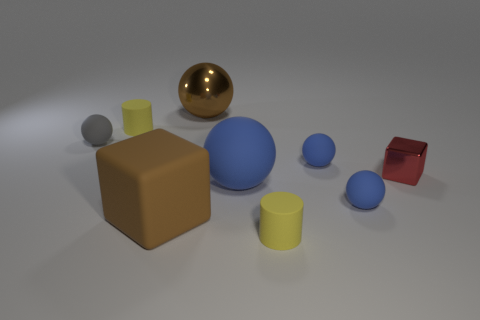What number of other things are there of the same size as the gray matte sphere?
Provide a short and direct response. 5. What number of objects are either blue balls behind the tiny cube or yellow rubber cylinders that are behind the tiny red shiny cube?
Your answer should be compact. 2. Do the big brown block and the tiny cylinder that is behind the red thing have the same material?
Offer a terse response. Yes. How many other objects are there of the same shape as the tiny red metal thing?
Make the answer very short. 1. There is a tiny ball that is on the left side of the yellow cylinder to the left of the small yellow thing in front of the big matte cube; what is it made of?
Keep it short and to the point. Rubber. Are there an equal number of tiny gray matte spheres on the right side of the big blue rubber object and purple cylinders?
Give a very brief answer. Yes. Is the block that is right of the brown ball made of the same material as the brown sphere to the right of the large brown cube?
Keep it short and to the point. Yes. There is a yellow matte object in front of the tiny gray matte ball; does it have the same shape as the big thing behind the tiny gray ball?
Ensure brevity in your answer.  No. Is the number of small yellow things behind the large brown shiny ball less than the number of large blue spheres?
Keep it short and to the point. Yes. How many matte cubes have the same color as the metallic ball?
Provide a succinct answer. 1. 